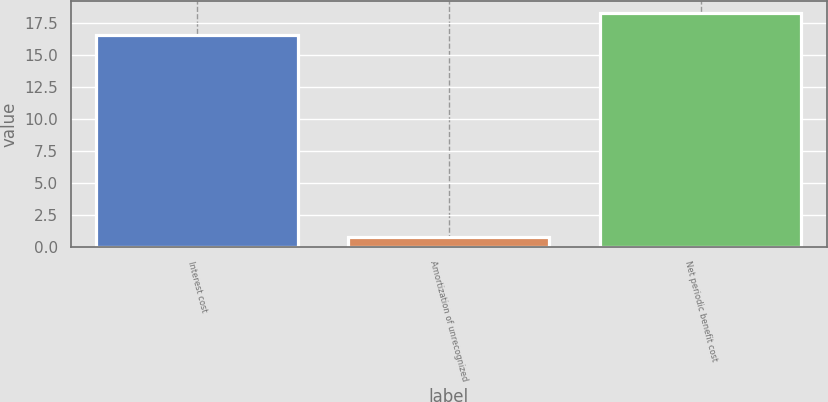Convert chart. <chart><loc_0><loc_0><loc_500><loc_500><bar_chart><fcel>Interest cost<fcel>Amortization of unrecognized<fcel>Net periodic benefit cost<nl><fcel>16.5<fcel>0.8<fcel>18.24<nl></chart> 